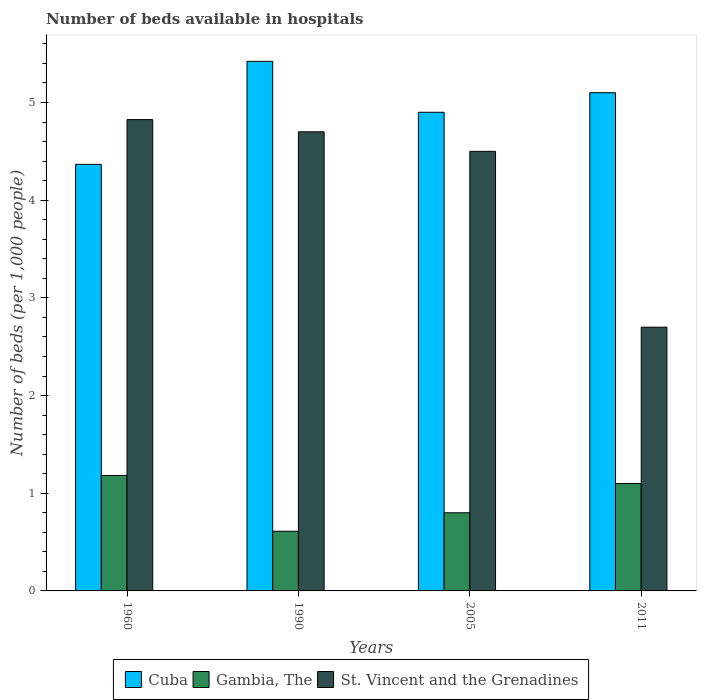How many different coloured bars are there?
Provide a short and direct response. 3. How many groups of bars are there?
Give a very brief answer. 4. Are the number of bars on each tick of the X-axis equal?
Keep it short and to the point. Yes. How many bars are there on the 4th tick from the left?
Provide a short and direct response. 3. What is the number of beds in the hospiatls of in Gambia, The in 1960?
Your answer should be compact. 1.18. Across all years, what is the maximum number of beds in the hospiatls of in Cuba?
Make the answer very short. 5.42. Across all years, what is the minimum number of beds in the hospiatls of in Gambia, The?
Your response must be concise. 0.61. In which year was the number of beds in the hospiatls of in Gambia, The maximum?
Give a very brief answer. 1960. What is the total number of beds in the hospiatls of in St. Vincent and the Grenadines in the graph?
Provide a short and direct response. 16.72. What is the difference between the number of beds in the hospiatls of in Gambia, The in 1960 and that in 2011?
Your response must be concise. 0.08. What is the difference between the number of beds in the hospiatls of in St. Vincent and the Grenadines in 1960 and the number of beds in the hospiatls of in Gambia, The in 1990?
Provide a short and direct response. 4.21. What is the average number of beds in the hospiatls of in Gambia, The per year?
Your answer should be very brief. 0.92. In the year 2005, what is the difference between the number of beds in the hospiatls of in Cuba and number of beds in the hospiatls of in Gambia, The?
Offer a very short reply. 4.1. In how many years, is the number of beds in the hospiatls of in Cuba greater than 0.8?
Your answer should be very brief. 4. What is the ratio of the number of beds in the hospiatls of in St. Vincent and the Grenadines in 1960 to that in 2011?
Offer a very short reply. 1.79. Is the number of beds in the hospiatls of in Cuba in 1990 less than that in 2011?
Provide a short and direct response. No. What is the difference between the highest and the second highest number of beds in the hospiatls of in St. Vincent and the Grenadines?
Provide a succinct answer. 0.12. What is the difference between the highest and the lowest number of beds in the hospiatls of in Gambia, The?
Provide a short and direct response. 0.57. In how many years, is the number of beds in the hospiatls of in St. Vincent and the Grenadines greater than the average number of beds in the hospiatls of in St. Vincent and the Grenadines taken over all years?
Offer a terse response. 3. What does the 2nd bar from the left in 1990 represents?
Offer a very short reply. Gambia, The. What does the 3rd bar from the right in 1990 represents?
Give a very brief answer. Cuba. How many bars are there?
Offer a terse response. 12. What is the difference between two consecutive major ticks on the Y-axis?
Offer a terse response. 1. Does the graph contain grids?
Provide a short and direct response. No. Where does the legend appear in the graph?
Offer a terse response. Bottom center. What is the title of the graph?
Offer a terse response. Number of beds available in hospitals. Does "European Union" appear as one of the legend labels in the graph?
Your answer should be compact. No. What is the label or title of the Y-axis?
Keep it short and to the point. Number of beds (per 1,0 people). What is the Number of beds (per 1,000 people) in Cuba in 1960?
Provide a short and direct response. 4.37. What is the Number of beds (per 1,000 people) of Gambia, The in 1960?
Your answer should be compact. 1.18. What is the Number of beds (per 1,000 people) of St. Vincent and the Grenadines in 1960?
Provide a succinct answer. 4.82. What is the Number of beds (per 1,000 people) of Cuba in 1990?
Your answer should be very brief. 5.42. What is the Number of beds (per 1,000 people) in Gambia, The in 1990?
Ensure brevity in your answer.  0.61. What is the Number of beds (per 1,000 people) in St. Vincent and the Grenadines in 1990?
Offer a very short reply. 4.7. What is the Number of beds (per 1,000 people) in Cuba in 2005?
Your response must be concise. 4.9. What is the Number of beds (per 1,000 people) in St. Vincent and the Grenadines in 2005?
Your response must be concise. 4.5. What is the Number of beds (per 1,000 people) in Gambia, The in 2011?
Make the answer very short. 1.1. Across all years, what is the maximum Number of beds (per 1,000 people) of Cuba?
Make the answer very short. 5.42. Across all years, what is the maximum Number of beds (per 1,000 people) of Gambia, The?
Offer a very short reply. 1.18. Across all years, what is the maximum Number of beds (per 1,000 people) of St. Vincent and the Grenadines?
Offer a very short reply. 4.82. Across all years, what is the minimum Number of beds (per 1,000 people) in Cuba?
Your answer should be very brief. 4.37. Across all years, what is the minimum Number of beds (per 1,000 people) in Gambia, The?
Offer a terse response. 0.61. What is the total Number of beds (per 1,000 people) of Cuba in the graph?
Your answer should be compact. 19.79. What is the total Number of beds (per 1,000 people) in Gambia, The in the graph?
Provide a short and direct response. 3.69. What is the total Number of beds (per 1,000 people) in St. Vincent and the Grenadines in the graph?
Your response must be concise. 16.73. What is the difference between the Number of beds (per 1,000 people) in Cuba in 1960 and that in 1990?
Provide a succinct answer. -1.05. What is the difference between the Number of beds (per 1,000 people) of Gambia, The in 1960 and that in 1990?
Your response must be concise. 0.57. What is the difference between the Number of beds (per 1,000 people) of Cuba in 1960 and that in 2005?
Keep it short and to the point. -0.53. What is the difference between the Number of beds (per 1,000 people) in Gambia, The in 1960 and that in 2005?
Provide a short and direct response. 0.38. What is the difference between the Number of beds (per 1,000 people) in St. Vincent and the Grenadines in 1960 and that in 2005?
Your answer should be very brief. 0.33. What is the difference between the Number of beds (per 1,000 people) in Cuba in 1960 and that in 2011?
Your answer should be very brief. -0.73. What is the difference between the Number of beds (per 1,000 people) in Gambia, The in 1960 and that in 2011?
Offer a very short reply. 0.08. What is the difference between the Number of beds (per 1,000 people) of St. Vincent and the Grenadines in 1960 and that in 2011?
Provide a short and direct response. 2.12. What is the difference between the Number of beds (per 1,000 people) in Cuba in 1990 and that in 2005?
Provide a succinct answer. 0.52. What is the difference between the Number of beds (per 1,000 people) in Gambia, The in 1990 and that in 2005?
Your response must be concise. -0.19. What is the difference between the Number of beds (per 1,000 people) in Cuba in 1990 and that in 2011?
Give a very brief answer. 0.32. What is the difference between the Number of beds (per 1,000 people) in Gambia, The in 1990 and that in 2011?
Offer a very short reply. -0.49. What is the difference between the Number of beds (per 1,000 people) of Gambia, The in 2005 and that in 2011?
Offer a very short reply. -0.3. What is the difference between the Number of beds (per 1,000 people) in Cuba in 1960 and the Number of beds (per 1,000 people) in Gambia, The in 1990?
Your response must be concise. 3.76. What is the difference between the Number of beds (per 1,000 people) in Cuba in 1960 and the Number of beds (per 1,000 people) in St. Vincent and the Grenadines in 1990?
Give a very brief answer. -0.33. What is the difference between the Number of beds (per 1,000 people) in Gambia, The in 1960 and the Number of beds (per 1,000 people) in St. Vincent and the Grenadines in 1990?
Provide a succinct answer. -3.52. What is the difference between the Number of beds (per 1,000 people) of Cuba in 1960 and the Number of beds (per 1,000 people) of Gambia, The in 2005?
Make the answer very short. 3.57. What is the difference between the Number of beds (per 1,000 people) of Cuba in 1960 and the Number of beds (per 1,000 people) of St. Vincent and the Grenadines in 2005?
Your response must be concise. -0.13. What is the difference between the Number of beds (per 1,000 people) in Gambia, The in 1960 and the Number of beds (per 1,000 people) in St. Vincent and the Grenadines in 2005?
Your answer should be very brief. -3.32. What is the difference between the Number of beds (per 1,000 people) of Cuba in 1960 and the Number of beds (per 1,000 people) of Gambia, The in 2011?
Provide a short and direct response. 3.27. What is the difference between the Number of beds (per 1,000 people) of Cuba in 1960 and the Number of beds (per 1,000 people) of St. Vincent and the Grenadines in 2011?
Give a very brief answer. 1.67. What is the difference between the Number of beds (per 1,000 people) of Gambia, The in 1960 and the Number of beds (per 1,000 people) of St. Vincent and the Grenadines in 2011?
Give a very brief answer. -1.52. What is the difference between the Number of beds (per 1,000 people) in Cuba in 1990 and the Number of beds (per 1,000 people) in Gambia, The in 2005?
Keep it short and to the point. 4.62. What is the difference between the Number of beds (per 1,000 people) of Cuba in 1990 and the Number of beds (per 1,000 people) of St. Vincent and the Grenadines in 2005?
Your response must be concise. 0.92. What is the difference between the Number of beds (per 1,000 people) of Gambia, The in 1990 and the Number of beds (per 1,000 people) of St. Vincent and the Grenadines in 2005?
Make the answer very short. -3.89. What is the difference between the Number of beds (per 1,000 people) of Cuba in 1990 and the Number of beds (per 1,000 people) of Gambia, The in 2011?
Your response must be concise. 4.32. What is the difference between the Number of beds (per 1,000 people) in Cuba in 1990 and the Number of beds (per 1,000 people) in St. Vincent and the Grenadines in 2011?
Give a very brief answer. 2.72. What is the difference between the Number of beds (per 1,000 people) in Gambia, The in 1990 and the Number of beds (per 1,000 people) in St. Vincent and the Grenadines in 2011?
Provide a succinct answer. -2.09. What is the difference between the Number of beds (per 1,000 people) of Cuba in 2005 and the Number of beds (per 1,000 people) of Gambia, The in 2011?
Provide a short and direct response. 3.8. What is the average Number of beds (per 1,000 people) in Cuba per year?
Your answer should be compact. 4.95. What is the average Number of beds (per 1,000 people) in Gambia, The per year?
Your response must be concise. 0.92. What is the average Number of beds (per 1,000 people) of St. Vincent and the Grenadines per year?
Offer a terse response. 4.18. In the year 1960, what is the difference between the Number of beds (per 1,000 people) in Cuba and Number of beds (per 1,000 people) in Gambia, The?
Offer a terse response. 3.18. In the year 1960, what is the difference between the Number of beds (per 1,000 people) in Cuba and Number of beds (per 1,000 people) in St. Vincent and the Grenadines?
Provide a short and direct response. -0.46. In the year 1960, what is the difference between the Number of beds (per 1,000 people) in Gambia, The and Number of beds (per 1,000 people) in St. Vincent and the Grenadines?
Provide a short and direct response. -3.64. In the year 1990, what is the difference between the Number of beds (per 1,000 people) in Cuba and Number of beds (per 1,000 people) in Gambia, The?
Your answer should be compact. 4.81. In the year 1990, what is the difference between the Number of beds (per 1,000 people) in Cuba and Number of beds (per 1,000 people) in St. Vincent and the Grenadines?
Keep it short and to the point. 0.72. In the year 1990, what is the difference between the Number of beds (per 1,000 people) of Gambia, The and Number of beds (per 1,000 people) of St. Vincent and the Grenadines?
Your response must be concise. -4.09. In the year 2005, what is the difference between the Number of beds (per 1,000 people) of Cuba and Number of beds (per 1,000 people) of St. Vincent and the Grenadines?
Offer a very short reply. 0.4. In the year 2011, what is the difference between the Number of beds (per 1,000 people) in Cuba and Number of beds (per 1,000 people) in St. Vincent and the Grenadines?
Your answer should be very brief. 2.4. What is the ratio of the Number of beds (per 1,000 people) in Cuba in 1960 to that in 1990?
Offer a terse response. 0.81. What is the ratio of the Number of beds (per 1,000 people) in Gambia, The in 1960 to that in 1990?
Ensure brevity in your answer.  1.93. What is the ratio of the Number of beds (per 1,000 people) in St. Vincent and the Grenadines in 1960 to that in 1990?
Your answer should be very brief. 1.03. What is the ratio of the Number of beds (per 1,000 people) in Cuba in 1960 to that in 2005?
Ensure brevity in your answer.  0.89. What is the ratio of the Number of beds (per 1,000 people) of Gambia, The in 1960 to that in 2005?
Offer a terse response. 1.48. What is the ratio of the Number of beds (per 1,000 people) in St. Vincent and the Grenadines in 1960 to that in 2005?
Your answer should be compact. 1.07. What is the ratio of the Number of beds (per 1,000 people) of Cuba in 1960 to that in 2011?
Your response must be concise. 0.86. What is the ratio of the Number of beds (per 1,000 people) in Gambia, The in 1960 to that in 2011?
Ensure brevity in your answer.  1.07. What is the ratio of the Number of beds (per 1,000 people) in St. Vincent and the Grenadines in 1960 to that in 2011?
Offer a terse response. 1.79. What is the ratio of the Number of beds (per 1,000 people) of Cuba in 1990 to that in 2005?
Give a very brief answer. 1.11. What is the ratio of the Number of beds (per 1,000 people) in Gambia, The in 1990 to that in 2005?
Your response must be concise. 0.76. What is the ratio of the Number of beds (per 1,000 people) of St. Vincent and the Grenadines in 1990 to that in 2005?
Keep it short and to the point. 1.04. What is the ratio of the Number of beds (per 1,000 people) of Cuba in 1990 to that in 2011?
Make the answer very short. 1.06. What is the ratio of the Number of beds (per 1,000 people) in Gambia, The in 1990 to that in 2011?
Provide a short and direct response. 0.56. What is the ratio of the Number of beds (per 1,000 people) of St. Vincent and the Grenadines in 1990 to that in 2011?
Make the answer very short. 1.74. What is the ratio of the Number of beds (per 1,000 people) of Cuba in 2005 to that in 2011?
Provide a short and direct response. 0.96. What is the ratio of the Number of beds (per 1,000 people) of Gambia, The in 2005 to that in 2011?
Offer a very short reply. 0.73. What is the ratio of the Number of beds (per 1,000 people) in St. Vincent and the Grenadines in 2005 to that in 2011?
Keep it short and to the point. 1.67. What is the difference between the highest and the second highest Number of beds (per 1,000 people) in Cuba?
Your answer should be compact. 0.32. What is the difference between the highest and the second highest Number of beds (per 1,000 people) in Gambia, The?
Offer a very short reply. 0.08. What is the difference between the highest and the second highest Number of beds (per 1,000 people) of St. Vincent and the Grenadines?
Ensure brevity in your answer.  0.12. What is the difference between the highest and the lowest Number of beds (per 1,000 people) in Cuba?
Offer a terse response. 1.05. What is the difference between the highest and the lowest Number of beds (per 1,000 people) in Gambia, The?
Offer a terse response. 0.57. What is the difference between the highest and the lowest Number of beds (per 1,000 people) in St. Vincent and the Grenadines?
Make the answer very short. 2.12. 